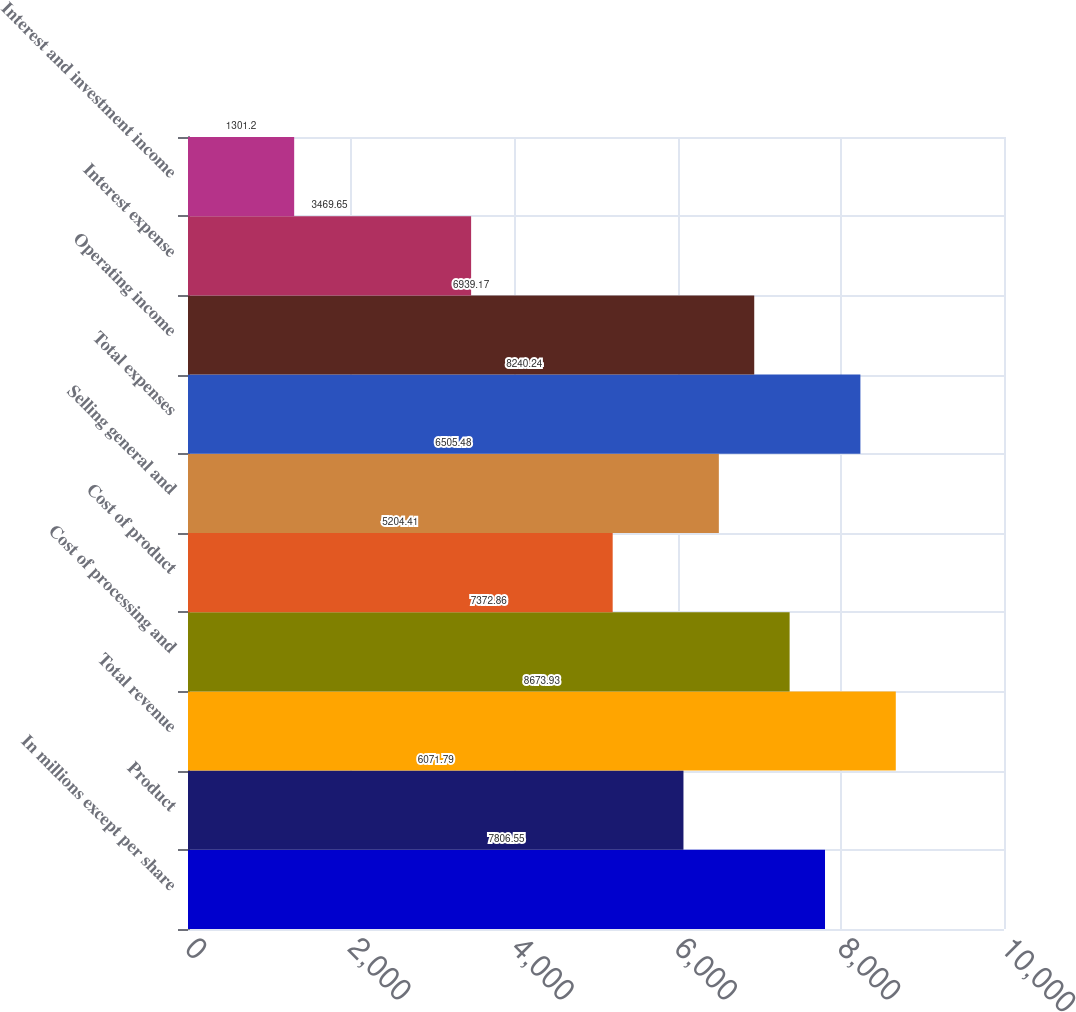<chart> <loc_0><loc_0><loc_500><loc_500><bar_chart><fcel>In millions except per share<fcel>Product<fcel>Total revenue<fcel>Cost of processing and<fcel>Cost of product<fcel>Selling general and<fcel>Total expenses<fcel>Operating income<fcel>Interest expense<fcel>Interest and investment income<nl><fcel>7806.55<fcel>6071.79<fcel>8673.93<fcel>7372.86<fcel>5204.41<fcel>6505.48<fcel>8240.24<fcel>6939.17<fcel>3469.65<fcel>1301.2<nl></chart> 